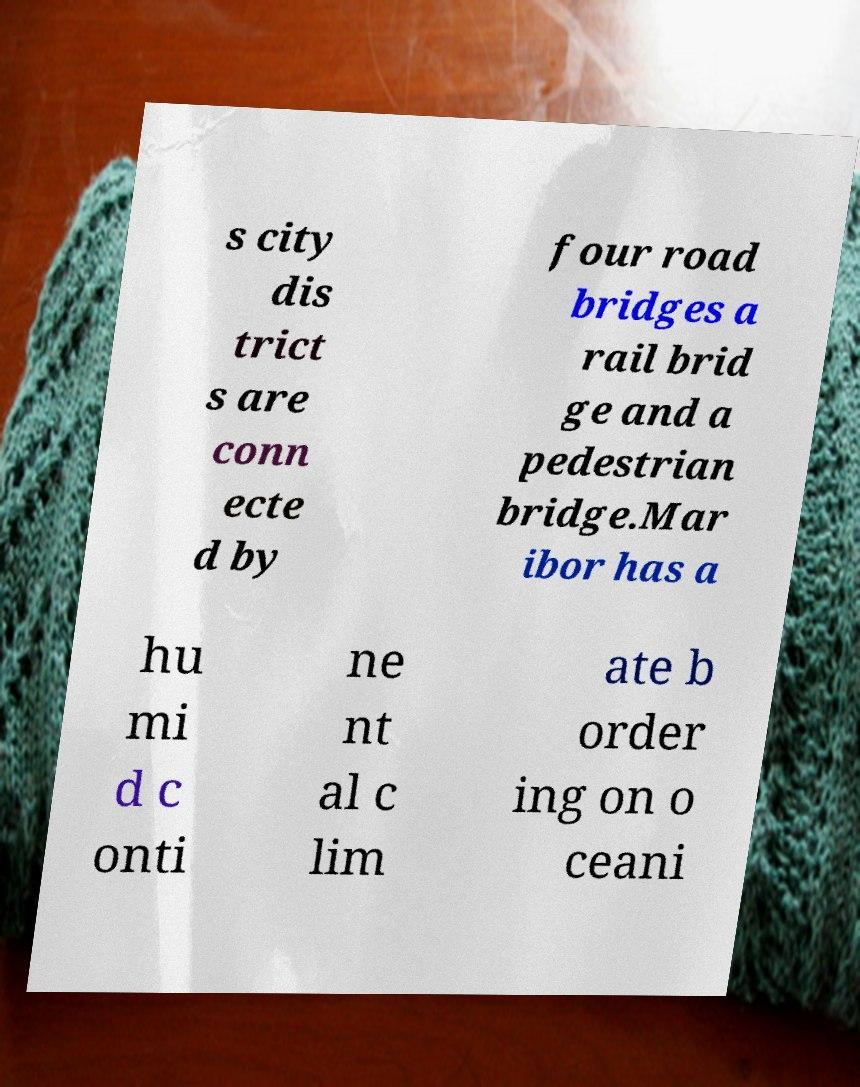What messages or text are displayed in this image? I need them in a readable, typed format. s city dis trict s are conn ecte d by four road bridges a rail brid ge and a pedestrian bridge.Mar ibor has a hu mi d c onti ne nt al c lim ate b order ing on o ceani 